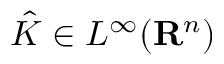Convert formula to latex. <formula><loc_0><loc_0><loc_500><loc_500>{ \hat { K } } \in L ^ { \infty } ( R ^ { n } )</formula> 